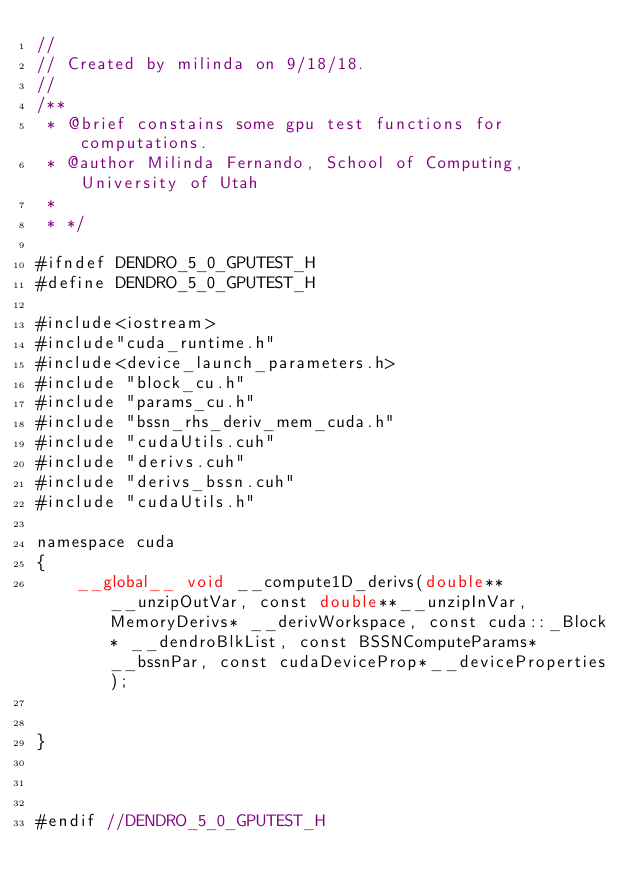Convert code to text. <code><loc_0><loc_0><loc_500><loc_500><_Cuda_>//
// Created by milinda on 9/18/18.
//
/**
 * @brief constains some gpu test functions for computations.
 * @author Milinda Fernando, School of Computing, University of Utah
 *
 * */

#ifndef DENDRO_5_0_GPUTEST_H
#define DENDRO_5_0_GPUTEST_H

#include<iostream>
#include"cuda_runtime.h"
#include<device_launch_parameters.h>
#include "block_cu.h"
#include "params_cu.h"
#include "bssn_rhs_deriv_mem_cuda.h"
#include "cudaUtils.cuh"
#include "derivs.cuh"
#include "derivs_bssn.cuh"
#include "cudaUtils.h"

namespace cuda
{
    __global__ void __compute1D_derivs(double** __unzipOutVar, const double**__unzipInVar, MemoryDerivs* __derivWorkspace, const cuda::_Block* __dendroBlkList, const BSSNComputeParams* __bssnPar, const cudaDeviceProp*__deviceProperties);


}



#endif //DENDRO_5_0_GPUTEST_H
</code> 